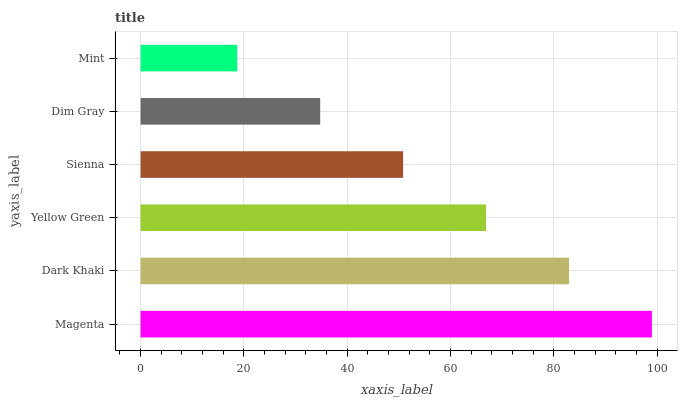Is Mint the minimum?
Answer yes or no. Yes. Is Magenta the maximum?
Answer yes or no. Yes. Is Dark Khaki the minimum?
Answer yes or no. No. Is Dark Khaki the maximum?
Answer yes or no. No. Is Magenta greater than Dark Khaki?
Answer yes or no. Yes. Is Dark Khaki less than Magenta?
Answer yes or no. Yes. Is Dark Khaki greater than Magenta?
Answer yes or no. No. Is Magenta less than Dark Khaki?
Answer yes or no. No. Is Yellow Green the high median?
Answer yes or no. Yes. Is Sienna the low median?
Answer yes or no. Yes. Is Dark Khaki the high median?
Answer yes or no. No. Is Mint the low median?
Answer yes or no. No. 